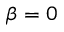<formula> <loc_0><loc_0><loc_500><loc_500>\beta = 0</formula> 